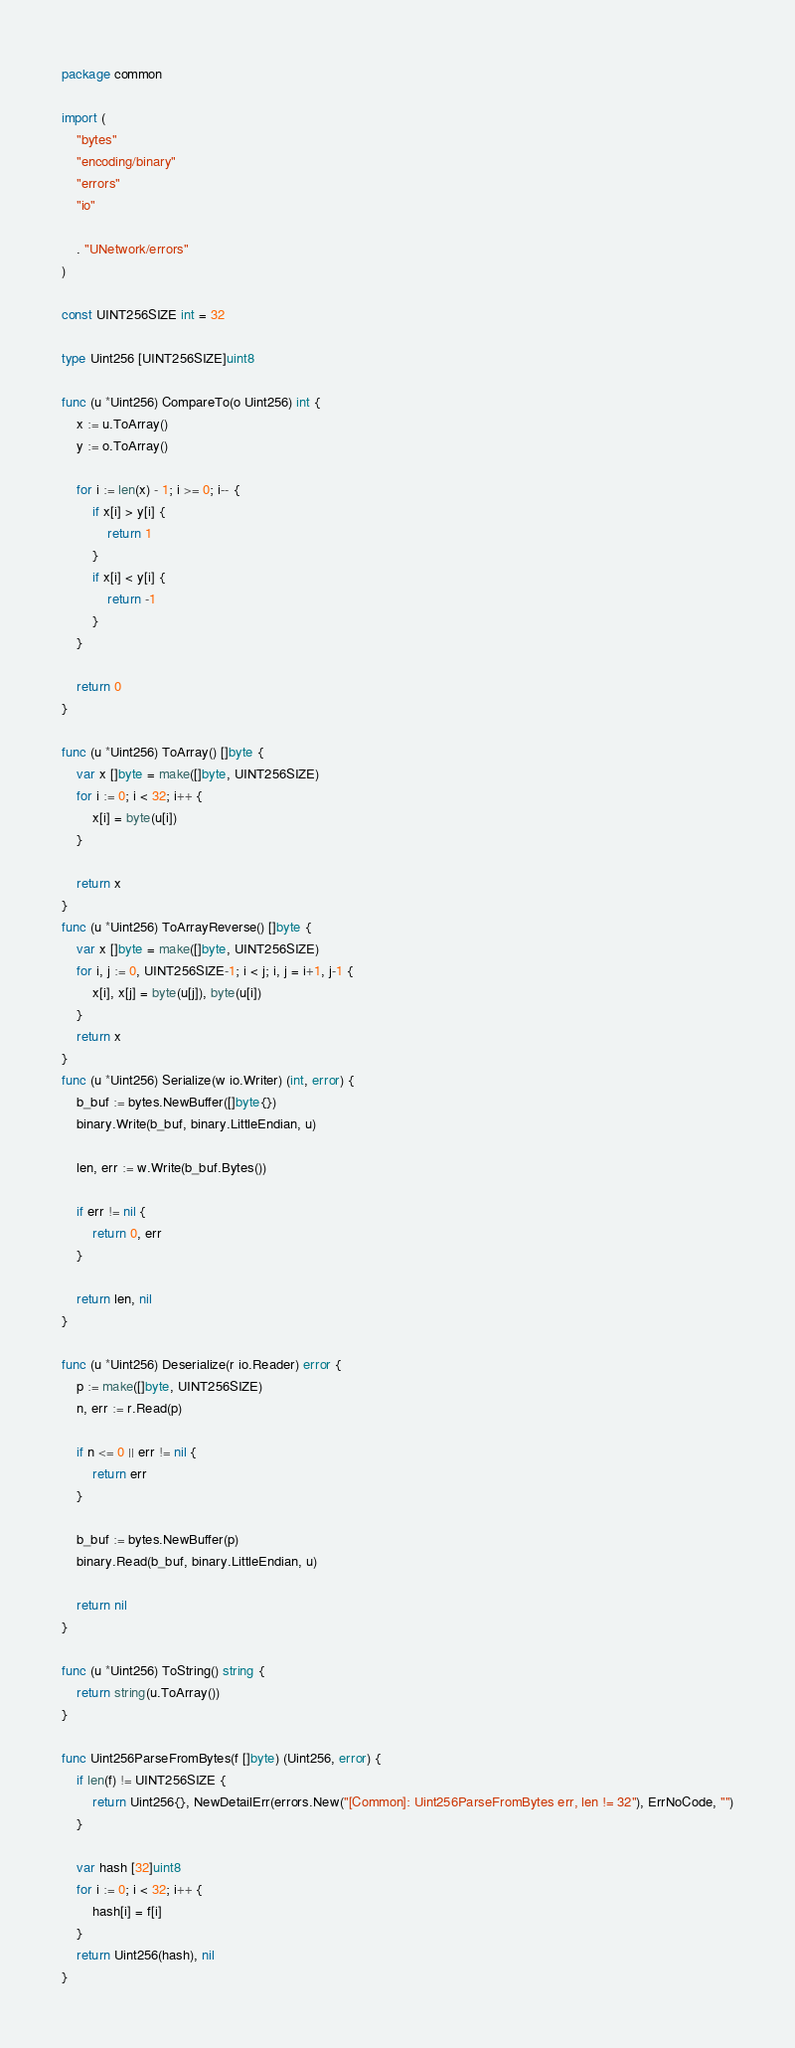Convert code to text. <code><loc_0><loc_0><loc_500><loc_500><_Go_>package common

import (
	"bytes"
	"encoding/binary"
	"errors"
	"io"

	. "UNetwork/errors"
)

const UINT256SIZE int = 32

type Uint256 [UINT256SIZE]uint8

func (u *Uint256) CompareTo(o Uint256) int {
	x := u.ToArray()
	y := o.ToArray()

	for i := len(x) - 1; i >= 0; i-- {
		if x[i] > y[i] {
			return 1
		}
		if x[i] < y[i] {
			return -1
		}
	}

	return 0
}

func (u *Uint256) ToArray() []byte {
	var x []byte = make([]byte, UINT256SIZE)
	for i := 0; i < 32; i++ {
		x[i] = byte(u[i])
	}

	return x
}
func (u *Uint256) ToArrayReverse() []byte {
	var x []byte = make([]byte, UINT256SIZE)
	for i, j := 0, UINT256SIZE-1; i < j; i, j = i+1, j-1 {
		x[i], x[j] = byte(u[j]), byte(u[i])
	}
	return x
}
func (u *Uint256) Serialize(w io.Writer) (int, error) {
	b_buf := bytes.NewBuffer([]byte{})
	binary.Write(b_buf, binary.LittleEndian, u)

	len, err := w.Write(b_buf.Bytes())

	if err != nil {
		return 0, err
	}

	return len, nil
}

func (u *Uint256) Deserialize(r io.Reader) error {
	p := make([]byte, UINT256SIZE)
	n, err := r.Read(p)

	if n <= 0 || err != nil {
		return err
	}

	b_buf := bytes.NewBuffer(p)
	binary.Read(b_buf, binary.LittleEndian, u)

	return nil
}

func (u *Uint256) ToString() string {
	return string(u.ToArray())
}

func Uint256ParseFromBytes(f []byte) (Uint256, error) {
	if len(f) != UINT256SIZE {
		return Uint256{}, NewDetailErr(errors.New("[Common]: Uint256ParseFromBytes err, len != 32"), ErrNoCode, "")
	}

	var hash [32]uint8
	for i := 0; i < 32; i++ {
		hash[i] = f[i]
	}
	return Uint256(hash), nil
}
</code> 